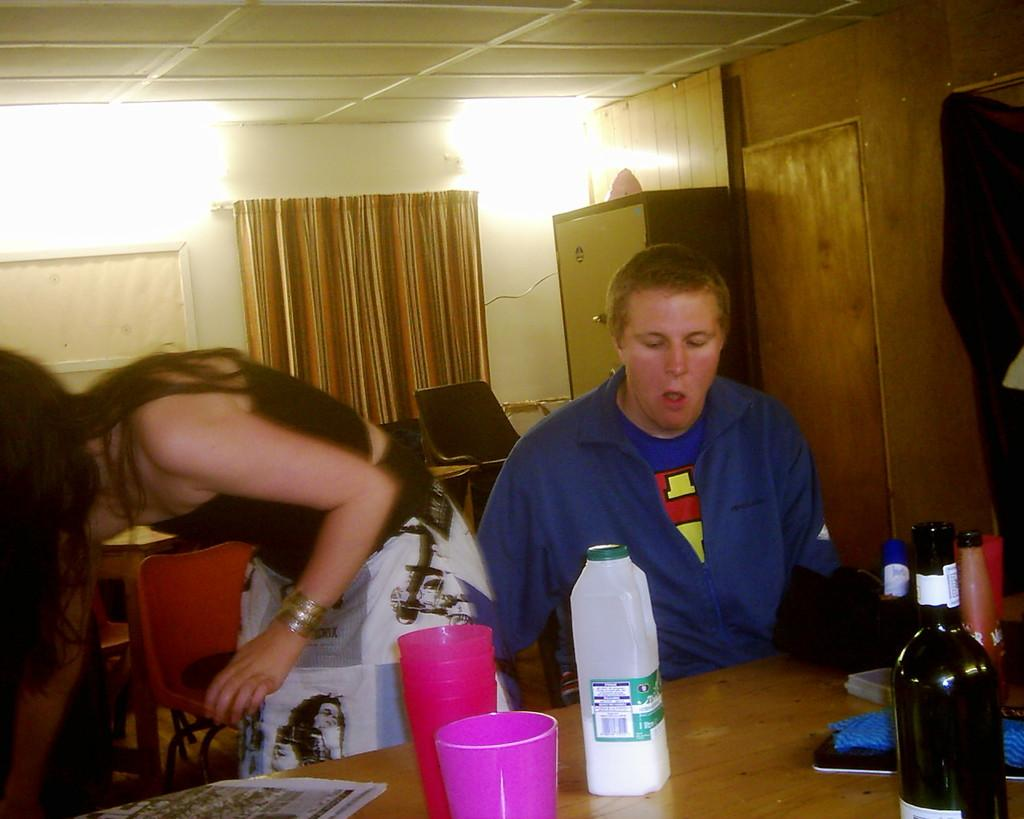How many people are in the image? There are two people in the image. What is the position of one of the people? One person is sitting. What is in front of the sitting person? There is a table in front of the sitting person. What items can be seen on the table? There are bottles and glasses on the table. What can be seen in the background of the image? There is a curtain visible in the background. What type of writer is sitting at the table in the image? There is no writer present in the image; it only shows two people and a table with bottles and glasses. How many fingers does the sitting person have in the image? The image does not show the fingers of the sitting person, so it cannot be determined from the image. 